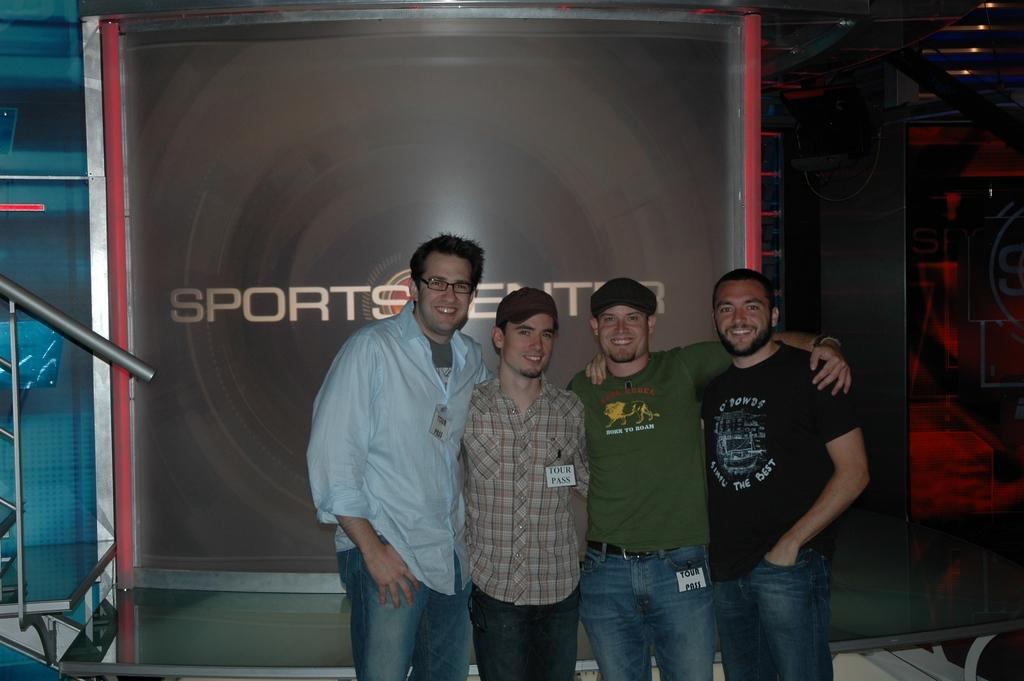How many people are in the image? There are four persons standing in the center of the image. What can be seen in the background of the image? There is a banner with text in the background of the image. What is located to the left side of the image? There is a railing to the left side of the image. How many boys are attempting to flex their muscles in the image? There is no information about boys or muscle flexing in the image; it only shows four persons standing in the center. 